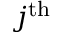Convert formula to latex. <formula><loc_0><loc_0><loc_500><loc_500>j ^ { t h }</formula> 